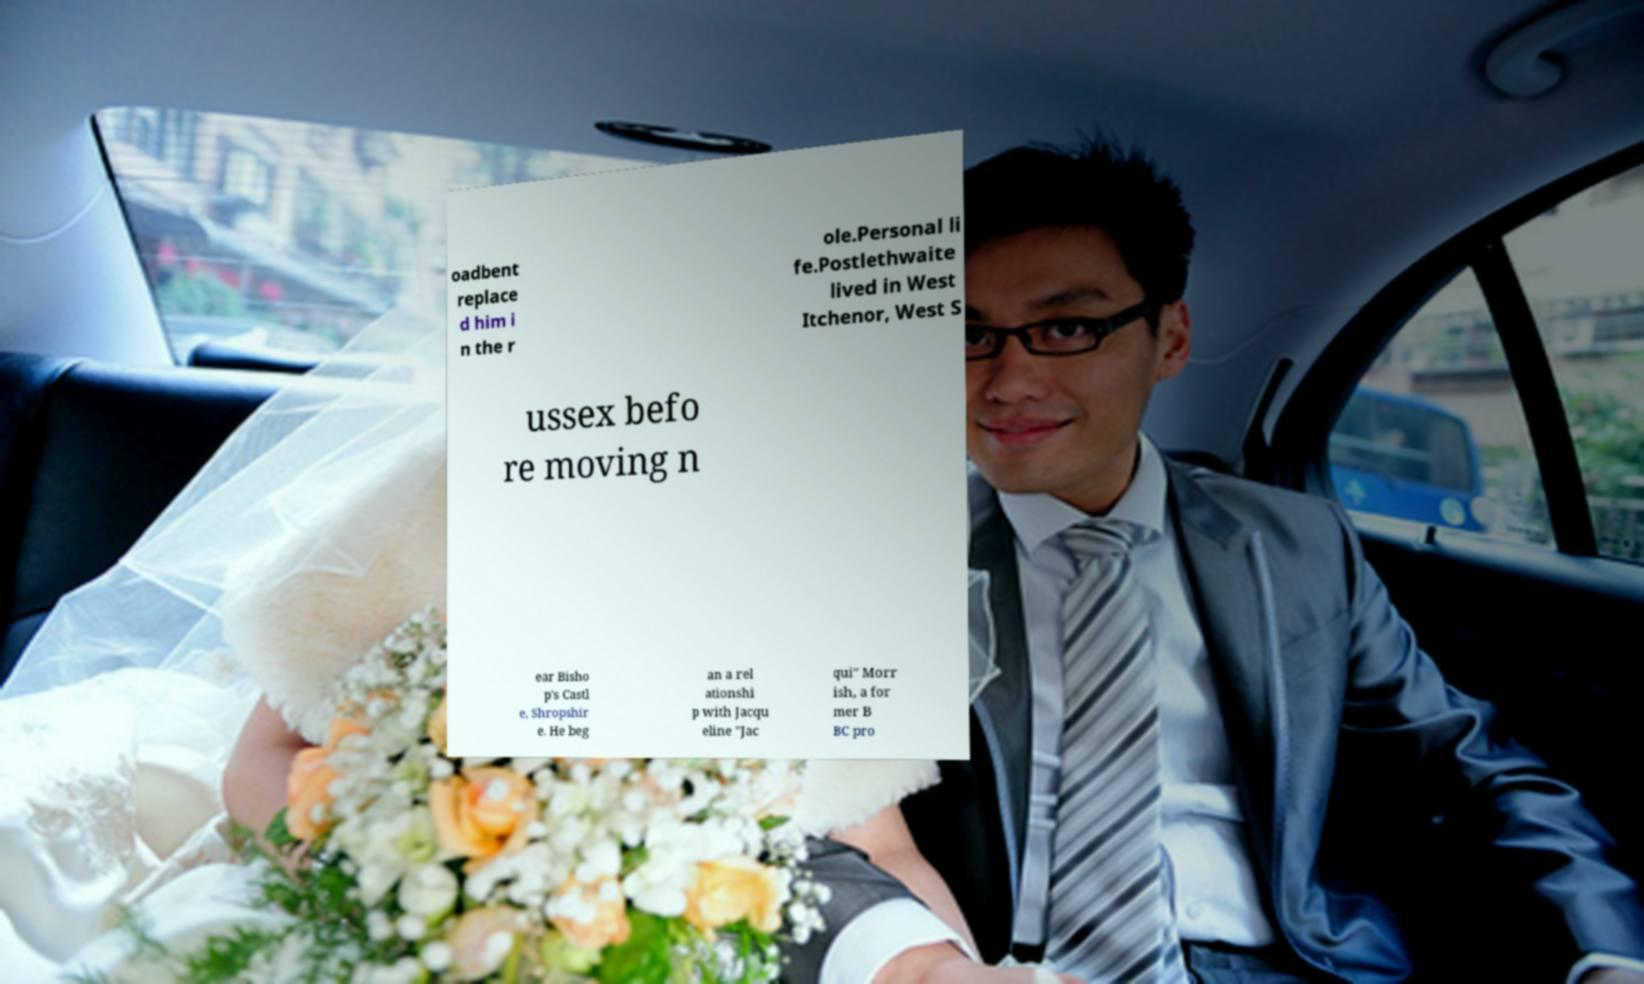Could you assist in decoding the text presented in this image and type it out clearly? oadbent replace d him i n the r ole.Personal li fe.Postlethwaite lived in West Itchenor, West S ussex befo re moving n ear Bisho p's Castl e, Shropshir e. He beg an a rel ationshi p with Jacqu eline "Jac qui" Morr ish, a for mer B BC pro 